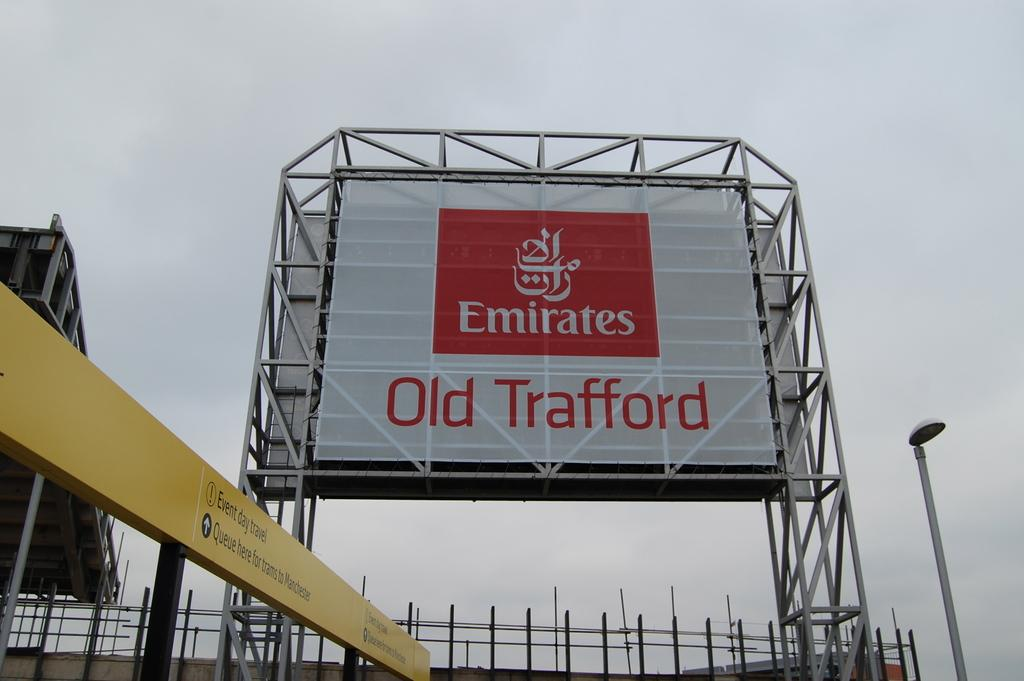<image>
Summarize the visual content of the image. A cloudy sky is behind a large sign for Emirates Old Trafford. 